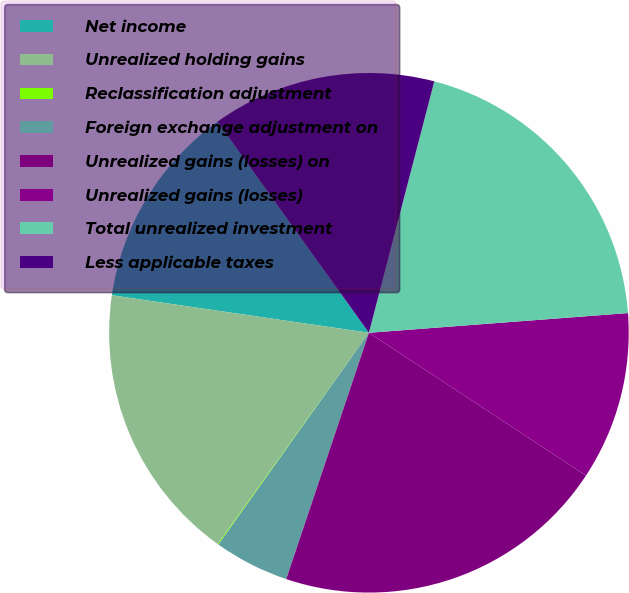<chart> <loc_0><loc_0><loc_500><loc_500><pie_chart><fcel>Net income<fcel>Unrealized holding gains<fcel>Reclassification adjustment<fcel>Foreign exchange adjustment on<fcel>Unrealized gains (losses) on<fcel>Unrealized gains (losses)<fcel>Total unrealized investment<fcel>Less applicable taxes<nl><fcel>12.79%<fcel>17.42%<fcel>0.05%<fcel>4.68%<fcel>20.89%<fcel>10.47%<fcel>19.74%<fcel>13.95%<nl></chart> 